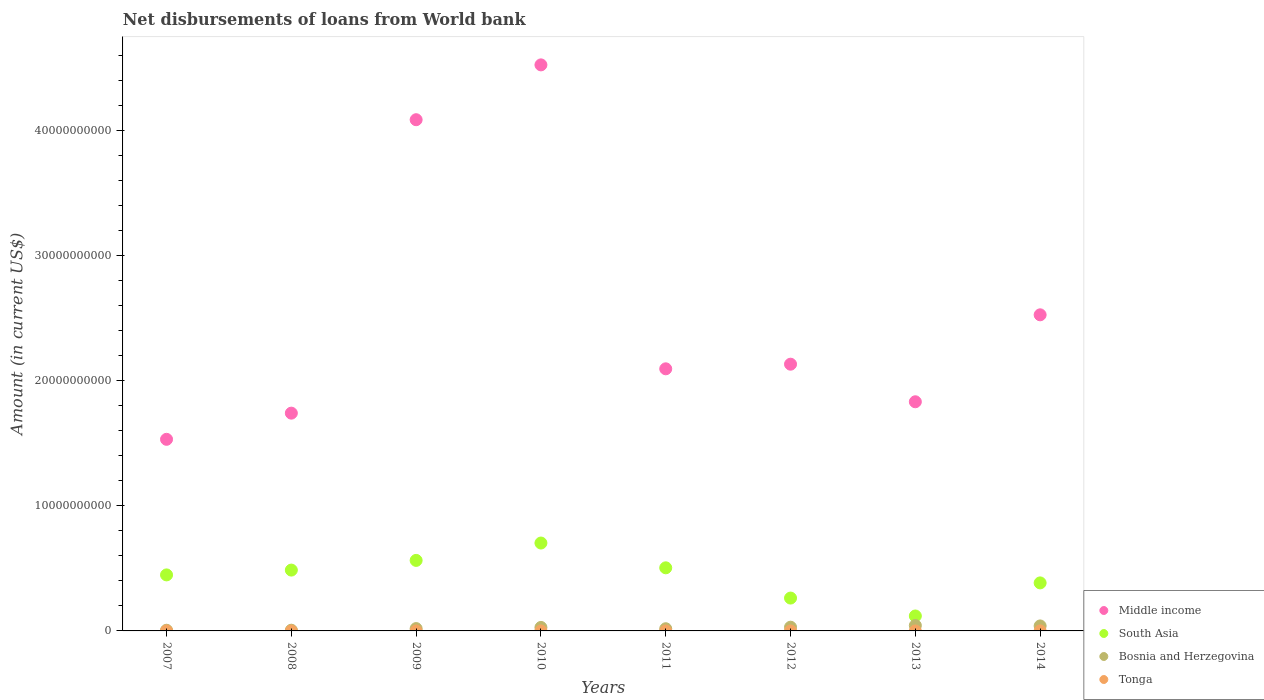What is the amount of loan disbursed from World Bank in South Asia in 2010?
Your answer should be compact. 7.02e+09. Across all years, what is the maximum amount of loan disbursed from World Bank in Middle income?
Keep it short and to the point. 4.52e+1. Across all years, what is the minimum amount of loan disbursed from World Bank in South Asia?
Your answer should be very brief. 1.19e+09. In which year was the amount of loan disbursed from World Bank in South Asia maximum?
Provide a succinct answer. 2010. What is the total amount of loan disbursed from World Bank in Bosnia and Herzegovina in the graph?
Make the answer very short. 1.88e+09. What is the difference between the amount of loan disbursed from World Bank in Middle income in 2008 and that in 2013?
Make the answer very short. -9.09e+08. What is the difference between the amount of loan disbursed from World Bank in Middle income in 2011 and the amount of loan disbursed from World Bank in Bosnia and Herzegovina in 2009?
Make the answer very short. 2.08e+1. What is the average amount of loan disbursed from World Bank in Tonga per year?
Offer a very short reply. 5.67e+05. In the year 2011, what is the difference between the amount of loan disbursed from World Bank in Bosnia and Herzegovina and amount of loan disbursed from World Bank in South Asia?
Keep it short and to the point. -4.87e+09. What is the ratio of the amount of loan disbursed from World Bank in Middle income in 2008 to that in 2012?
Provide a succinct answer. 0.82. Is the amount of loan disbursed from World Bank in Tonga in 2007 less than that in 2009?
Provide a succinct answer. No. Is the difference between the amount of loan disbursed from World Bank in Bosnia and Herzegovina in 2007 and 2008 greater than the difference between the amount of loan disbursed from World Bank in South Asia in 2007 and 2008?
Offer a terse response. Yes. What is the difference between the highest and the second highest amount of loan disbursed from World Bank in South Asia?
Ensure brevity in your answer.  1.39e+09. What is the difference between the highest and the lowest amount of loan disbursed from World Bank in Tonga?
Offer a terse response. 2.32e+06. Is the sum of the amount of loan disbursed from World Bank in Bosnia and Herzegovina in 2009 and 2012 greater than the maximum amount of loan disbursed from World Bank in Tonga across all years?
Ensure brevity in your answer.  Yes. Is it the case that in every year, the sum of the amount of loan disbursed from World Bank in Middle income and amount of loan disbursed from World Bank in Bosnia and Herzegovina  is greater than the amount of loan disbursed from World Bank in Tonga?
Give a very brief answer. Yes. Does the amount of loan disbursed from World Bank in Tonga monotonically increase over the years?
Offer a very short reply. No. Is the amount of loan disbursed from World Bank in Bosnia and Herzegovina strictly greater than the amount of loan disbursed from World Bank in South Asia over the years?
Provide a short and direct response. No. What is the difference between two consecutive major ticks on the Y-axis?
Your answer should be very brief. 1.00e+1. Does the graph contain any zero values?
Offer a very short reply. Yes. Where does the legend appear in the graph?
Your response must be concise. Bottom right. What is the title of the graph?
Your answer should be compact. Net disbursements of loans from World bank. Does "West Bank and Gaza" appear as one of the legend labels in the graph?
Keep it short and to the point. No. What is the label or title of the Y-axis?
Your response must be concise. Amount (in current US$). What is the Amount (in current US$) in Middle income in 2007?
Offer a terse response. 1.53e+1. What is the Amount (in current US$) of South Asia in 2007?
Give a very brief answer. 4.48e+09. What is the Amount (in current US$) of Bosnia and Herzegovina in 2007?
Your answer should be very brief. 5.48e+07. What is the Amount (in current US$) in Tonga in 2007?
Make the answer very short. 2.32e+06. What is the Amount (in current US$) of Middle income in 2008?
Your answer should be very brief. 1.74e+1. What is the Amount (in current US$) of South Asia in 2008?
Ensure brevity in your answer.  4.86e+09. What is the Amount (in current US$) in Bosnia and Herzegovina in 2008?
Offer a terse response. 5.72e+07. What is the Amount (in current US$) of Middle income in 2009?
Offer a terse response. 4.08e+1. What is the Amount (in current US$) of South Asia in 2009?
Keep it short and to the point. 5.63e+09. What is the Amount (in current US$) in Bosnia and Herzegovina in 2009?
Provide a short and direct response. 1.87e+08. What is the Amount (in current US$) in Tonga in 2009?
Offer a terse response. 5.30e+04. What is the Amount (in current US$) of Middle income in 2010?
Your answer should be very brief. 4.52e+1. What is the Amount (in current US$) of South Asia in 2010?
Your answer should be very brief. 7.02e+09. What is the Amount (in current US$) in Bosnia and Herzegovina in 2010?
Your answer should be very brief. 2.78e+08. What is the Amount (in current US$) of Middle income in 2011?
Provide a short and direct response. 2.09e+1. What is the Amount (in current US$) in South Asia in 2011?
Make the answer very short. 5.04e+09. What is the Amount (in current US$) of Bosnia and Herzegovina in 2011?
Make the answer very short. 1.75e+08. What is the Amount (in current US$) in Middle income in 2012?
Offer a very short reply. 2.13e+1. What is the Amount (in current US$) of South Asia in 2012?
Ensure brevity in your answer.  2.63e+09. What is the Amount (in current US$) of Bosnia and Herzegovina in 2012?
Keep it short and to the point. 2.98e+08. What is the Amount (in current US$) in Middle income in 2013?
Your answer should be compact. 1.83e+1. What is the Amount (in current US$) of South Asia in 2013?
Your response must be concise. 1.19e+09. What is the Amount (in current US$) of Bosnia and Herzegovina in 2013?
Provide a succinct answer. 4.33e+08. What is the Amount (in current US$) of Middle income in 2014?
Your answer should be compact. 2.53e+1. What is the Amount (in current US$) in South Asia in 2014?
Your answer should be compact. 3.84e+09. What is the Amount (in current US$) in Bosnia and Herzegovina in 2014?
Your answer should be compact. 3.98e+08. What is the Amount (in current US$) in Tonga in 2014?
Your answer should be very brief. 2.16e+06. Across all years, what is the maximum Amount (in current US$) in Middle income?
Your response must be concise. 4.52e+1. Across all years, what is the maximum Amount (in current US$) in South Asia?
Provide a short and direct response. 7.02e+09. Across all years, what is the maximum Amount (in current US$) of Bosnia and Herzegovina?
Ensure brevity in your answer.  4.33e+08. Across all years, what is the maximum Amount (in current US$) in Tonga?
Your answer should be very brief. 2.32e+06. Across all years, what is the minimum Amount (in current US$) in Middle income?
Provide a succinct answer. 1.53e+1. Across all years, what is the minimum Amount (in current US$) in South Asia?
Make the answer very short. 1.19e+09. Across all years, what is the minimum Amount (in current US$) of Bosnia and Herzegovina?
Keep it short and to the point. 5.48e+07. Across all years, what is the minimum Amount (in current US$) of Tonga?
Give a very brief answer. 0. What is the total Amount (in current US$) of Middle income in the graph?
Offer a very short reply. 2.05e+11. What is the total Amount (in current US$) in South Asia in the graph?
Your answer should be very brief. 3.47e+1. What is the total Amount (in current US$) of Bosnia and Herzegovina in the graph?
Give a very brief answer. 1.88e+09. What is the total Amount (in current US$) in Tonga in the graph?
Give a very brief answer. 4.54e+06. What is the difference between the Amount (in current US$) in Middle income in 2007 and that in 2008?
Your answer should be very brief. -2.09e+09. What is the difference between the Amount (in current US$) in South Asia in 2007 and that in 2008?
Your answer should be compact. -3.85e+08. What is the difference between the Amount (in current US$) in Bosnia and Herzegovina in 2007 and that in 2008?
Give a very brief answer. -2.36e+06. What is the difference between the Amount (in current US$) in Middle income in 2007 and that in 2009?
Your answer should be very brief. -2.55e+1. What is the difference between the Amount (in current US$) in South Asia in 2007 and that in 2009?
Your answer should be very brief. -1.16e+09. What is the difference between the Amount (in current US$) of Bosnia and Herzegovina in 2007 and that in 2009?
Your response must be concise. -1.32e+08. What is the difference between the Amount (in current US$) of Tonga in 2007 and that in 2009?
Ensure brevity in your answer.  2.27e+06. What is the difference between the Amount (in current US$) of Middle income in 2007 and that in 2010?
Provide a short and direct response. -2.99e+1. What is the difference between the Amount (in current US$) in South Asia in 2007 and that in 2010?
Give a very brief answer. -2.55e+09. What is the difference between the Amount (in current US$) in Bosnia and Herzegovina in 2007 and that in 2010?
Your response must be concise. -2.23e+08. What is the difference between the Amount (in current US$) in Middle income in 2007 and that in 2011?
Ensure brevity in your answer.  -5.63e+09. What is the difference between the Amount (in current US$) in South Asia in 2007 and that in 2011?
Offer a terse response. -5.66e+08. What is the difference between the Amount (in current US$) in Bosnia and Herzegovina in 2007 and that in 2011?
Provide a succinct answer. -1.20e+08. What is the difference between the Amount (in current US$) of Middle income in 2007 and that in 2012?
Your response must be concise. -6.00e+09. What is the difference between the Amount (in current US$) of South Asia in 2007 and that in 2012?
Provide a short and direct response. 1.85e+09. What is the difference between the Amount (in current US$) in Bosnia and Herzegovina in 2007 and that in 2012?
Your answer should be very brief. -2.43e+08. What is the difference between the Amount (in current US$) of Middle income in 2007 and that in 2013?
Keep it short and to the point. -3.00e+09. What is the difference between the Amount (in current US$) in South Asia in 2007 and that in 2013?
Your answer should be very brief. 3.28e+09. What is the difference between the Amount (in current US$) in Bosnia and Herzegovina in 2007 and that in 2013?
Give a very brief answer. -3.78e+08. What is the difference between the Amount (in current US$) in Middle income in 2007 and that in 2014?
Your answer should be very brief. -9.95e+09. What is the difference between the Amount (in current US$) of South Asia in 2007 and that in 2014?
Your response must be concise. 6.39e+08. What is the difference between the Amount (in current US$) of Bosnia and Herzegovina in 2007 and that in 2014?
Provide a short and direct response. -3.43e+08. What is the difference between the Amount (in current US$) of Tonga in 2007 and that in 2014?
Your answer should be very brief. 1.64e+05. What is the difference between the Amount (in current US$) of Middle income in 2008 and that in 2009?
Offer a terse response. -2.34e+1. What is the difference between the Amount (in current US$) in South Asia in 2008 and that in 2009?
Offer a very short reply. -7.74e+08. What is the difference between the Amount (in current US$) of Bosnia and Herzegovina in 2008 and that in 2009?
Provide a succinct answer. -1.29e+08. What is the difference between the Amount (in current US$) of Middle income in 2008 and that in 2010?
Keep it short and to the point. -2.78e+1. What is the difference between the Amount (in current US$) of South Asia in 2008 and that in 2010?
Your answer should be very brief. -2.16e+09. What is the difference between the Amount (in current US$) in Bosnia and Herzegovina in 2008 and that in 2010?
Your answer should be very brief. -2.20e+08. What is the difference between the Amount (in current US$) of Middle income in 2008 and that in 2011?
Keep it short and to the point. -3.54e+09. What is the difference between the Amount (in current US$) of South Asia in 2008 and that in 2011?
Your answer should be compact. -1.82e+08. What is the difference between the Amount (in current US$) of Bosnia and Herzegovina in 2008 and that in 2011?
Your answer should be very brief. -1.18e+08. What is the difference between the Amount (in current US$) of Middle income in 2008 and that in 2012?
Provide a succinct answer. -3.91e+09. What is the difference between the Amount (in current US$) of South Asia in 2008 and that in 2012?
Provide a succinct answer. 2.24e+09. What is the difference between the Amount (in current US$) of Bosnia and Herzegovina in 2008 and that in 2012?
Your answer should be very brief. -2.41e+08. What is the difference between the Amount (in current US$) in Middle income in 2008 and that in 2013?
Your answer should be very brief. -9.09e+08. What is the difference between the Amount (in current US$) of South Asia in 2008 and that in 2013?
Provide a succinct answer. 3.67e+09. What is the difference between the Amount (in current US$) in Bosnia and Herzegovina in 2008 and that in 2013?
Your answer should be very brief. -3.76e+08. What is the difference between the Amount (in current US$) of Middle income in 2008 and that in 2014?
Keep it short and to the point. -7.86e+09. What is the difference between the Amount (in current US$) in South Asia in 2008 and that in 2014?
Your answer should be very brief. 1.02e+09. What is the difference between the Amount (in current US$) of Bosnia and Herzegovina in 2008 and that in 2014?
Give a very brief answer. -3.41e+08. What is the difference between the Amount (in current US$) in Middle income in 2009 and that in 2010?
Give a very brief answer. -4.38e+09. What is the difference between the Amount (in current US$) of South Asia in 2009 and that in 2010?
Make the answer very short. -1.39e+09. What is the difference between the Amount (in current US$) of Bosnia and Herzegovina in 2009 and that in 2010?
Make the answer very short. -9.10e+07. What is the difference between the Amount (in current US$) of Middle income in 2009 and that in 2011?
Your answer should be compact. 1.99e+1. What is the difference between the Amount (in current US$) of South Asia in 2009 and that in 2011?
Ensure brevity in your answer.  5.92e+08. What is the difference between the Amount (in current US$) in Bosnia and Herzegovina in 2009 and that in 2011?
Give a very brief answer. 1.18e+07. What is the difference between the Amount (in current US$) of Middle income in 2009 and that in 2012?
Give a very brief answer. 1.95e+1. What is the difference between the Amount (in current US$) in South Asia in 2009 and that in 2012?
Ensure brevity in your answer.  3.01e+09. What is the difference between the Amount (in current US$) of Bosnia and Herzegovina in 2009 and that in 2012?
Your response must be concise. -1.12e+08. What is the difference between the Amount (in current US$) in Middle income in 2009 and that in 2013?
Ensure brevity in your answer.  2.25e+1. What is the difference between the Amount (in current US$) in South Asia in 2009 and that in 2013?
Your response must be concise. 4.44e+09. What is the difference between the Amount (in current US$) in Bosnia and Herzegovina in 2009 and that in 2013?
Provide a short and direct response. -2.46e+08. What is the difference between the Amount (in current US$) in Middle income in 2009 and that in 2014?
Your answer should be very brief. 1.56e+1. What is the difference between the Amount (in current US$) in South Asia in 2009 and that in 2014?
Offer a very short reply. 1.80e+09. What is the difference between the Amount (in current US$) of Bosnia and Herzegovina in 2009 and that in 2014?
Provide a succinct answer. -2.12e+08. What is the difference between the Amount (in current US$) in Tonga in 2009 and that in 2014?
Provide a short and direct response. -2.11e+06. What is the difference between the Amount (in current US$) in Middle income in 2010 and that in 2011?
Your answer should be very brief. 2.43e+1. What is the difference between the Amount (in current US$) in South Asia in 2010 and that in 2011?
Offer a very short reply. 1.98e+09. What is the difference between the Amount (in current US$) of Bosnia and Herzegovina in 2010 and that in 2011?
Your answer should be compact. 1.03e+08. What is the difference between the Amount (in current US$) in Middle income in 2010 and that in 2012?
Ensure brevity in your answer.  2.39e+1. What is the difference between the Amount (in current US$) in South Asia in 2010 and that in 2012?
Keep it short and to the point. 4.40e+09. What is the difference between the Amount (in current US$) of Bosnia and Herzegovina in 2010 and that in 2012?
Provide a succinct answer. -2.07e+07. What is the difference between the Amount (in current US$) in Middle income in 2010 and that in 2013?
Offer a terse response. 2.69e+1. What is the difference between the Amount (in current US$) of South Asia in 2010 and that in 2013?
Ensure brevity in your answer.  5.83e+09. What is the difference between the Amount (in current US$) in Bosnia and Herzegovina in 2010 and that in 2013?
Your answer should be very brief. -1.55e+08. What is the difference between the Amount (in current US$) in Middle income in 2010 and that in 2014?
Offer a very short reply. 2.00e+1. What is the difference between the Amount (in current US$) in South Asia in 2010 and that in 2014?
Your answer should be very brief. 3.19e+09. What is the difference between the Amount (in current US$) in Bosnia and Herzegovina in 2010 and that in 2014?
Your answer should be very brief. -1.21e+08. What is the difference between the Amount (in current US$) of Middle income in 2011 and that in 2012?
Ensure brevity in your answer.  -3.69e+08. What is the difference between the Amount (in current US$) in South Asia in 2011 and that in 2012?
Offer a very short reply. 2.42e+09. What is the difference between the Amount (in current US$) of Bosnia and Herzegovina in 2011 and that in 2012?
Keep it short and to the point. -1.23e+08. What is the difference between the Amount (in current US$) in Middle income in 2011 and that in 2013?
Your answer should be very brief. 2.63e+09. What is the difference between the Amount (in current US$) in South Asia in 2011 and that in 2013?
Your answer should be very brief. 3.85e+09. What is the difference between the Amount (in current US$) of Bosnia and Herzegovina in 2011 and that in 2013?
Make the answer very short. -2.58e+08. What is the difference between the Amount (in current US$) in Middle income in 2011 and that in 2014?
Offer a very short reply. -4.31e+09. What is the difference between the Amount (in current US$) in South Asia in 2011 and that in 2014?
Your answer should be very brief. 1.21e+09. What is the difference between the Amount (in current US$) in Bosnia and Herzegovina in 2011 and that in 2014?
Offer a very short reply. -2.23e+08. What is the difference between the Amount (in current US$) of Middle income in 2012 and that in 2013?
Make the answer very short. 3.00e+09. What is the difference between the Amount (in current US$) of South Asia in 2012 and that in 2013?
Make the answer very short. 1.43e+09. What is the difference between the Amount (in current US$) of Bosnia and Herzegovina in 2012 and that in 2013?
Ensure brevity in your answer.  -1.35e+08. What is the difference between the Amount (in current US$) in Middle income in 2012 and that in 2014?
Ensure brevity in your answer.  -3.94e+09. What is the difference between the Amount (in current US$) of South Asia in 2012 and that in 2014?
Offer a very short reply. -1.21e+09. What is the difference between the Amount (in current US$) of Bosnia and Herzegovina in 2012 and that in 2014?
Ensure brevity in your answer.  -1.00e+08. What is the difference between the Amount (in current US$) of Middle income in 2013 and that in 2014?
Provide a short and direct response. -6.95e+09. What is the difference between the Amount (in current US$) of South Asia in 2013 and that in 2014?
Make the answer very short. -2.64e+09. What is the difference between the Amount (in current US$) of Bosnia and Herzegovina in 2013 and that in 2014?
Provide a succinct answer. 3.45e+07. What is the difference between the Amount (in current US$) of Middle income in 2007 and the Amount (in current US$) of South Asia in 2008?
Provide a short and direct response. 1.04e+1. What is the difference between the Amount (in current US$) in Middle income in 2007 and the Amount (in current US$) in Bosnia and Herzegovina in 2008?
Give a very brief answer. 1.53e+1. What is the difference between the Amount (in current US$) in South Asia in 2007 and the Amount (in current US$) in Bosnia and Herzegovina in 2008?
Your answer should be very brief. 4.42e+09. What is the difference between the Amount (in current US$) of Middle income in 2007 and the Amount (in current US$) of South Asia in 2009?
Ensure brevity in your answer.  9.67e+09. What is the difference between the Amount (in current US$) of Middle income in 2007 and the Amount (in current US$) of Bosnia and Herzegovina in 2009?
Give a very brief answer. 1.51e+1. What is the difference between the Amount (in current US$) in Middle income in 2007 and the Amount (in current US$) in Tonga in 2009?
Your answer should be compact. 1.53e+1. What is the difference between the Amount (in current US$) in South Asia in 2007 and the Amount (in current US$) in Bosnia and Herzegovina in 2009?
Keep it short and to the point. 4.29e+09. What is the difference between the Amount (in current US$) in South Asia in 2007 and the Amount (in current US$) in Tonga in 2009?
Offer a very short reply. 4.48e+09. What is the difference between the Amount (in current US$) of Bosnia and Herzegovina in 2007 and the Amount (in current US$) of Tonga in 2009?
Your answer should be very brief. 5.48e+07. What is the difference between the Amount (in current US$) of Middle income in 2007 and the Amount (in current US$) of South Asia in 2010?
Offer a very short reply. 8.29e+09. What is the difference between the Amount (in current US$) in Middle income in 2007 and the Amount (in current US$) in Bosnia and Herzegovina in 2010?
Offer a terse response. 1.50e+1. What is the difference between the Amount (in current US$) of South Asia in 2007 and the Amount (in current US$) of Bosnia and Herzegovina in 2010?
Your response must be concise. 4.20e+09. What is the difference between the Amount (in current US$) of Middle income in 2007 and the Amount (in current US$) of South Asia in 2011?
Your answer should be very brief. 1.03e+1. What is the difference between the Amount (in current US$) of Middle income in 2007 and the Amount (in current US$) of Bosnia and Herzegovina in 2011?
Provide a succinct answer. 1.51e+1. What is the difference between the Amount (in current US$) in South Asia in 2007 and the Amount (in current US$) in Bosnia and Herzegovina in 2011?
Your response must be concise. 4.30e+09. What is the difference between the Amount (in current US$) in Middle income in 2007 and the Amount (in current US$) in South Asia in 2012?
Offer a very short reply. 1.27e+1. What is the difference between the Amount (in current US$) of Middle income in 2007 and the Amount (in current US$) of Bosnia and Herzegovina in 2012?
Offer a terse response. 1.50e+1. What is the difference between the Amount (in current US$) in South Asia in 2007 and the Amount (in current US$) in Bosnia and Herzegovina in 2012?
Provide a short and direct response. 4.18e+09. What is the difference between the Amount (in current US$) in Middle income in 2007 and the Amount (in current US$) in South Asia in 2013?
Provide a succinct answer. 1.41e+1. What is the difference between the Amount (in current US$) in Middle income in 2007 and the Amount (in current US$) in Bosnia and Herzegovina in 2013?
Offer a terse response. 1.49e+1. What is the difference between the Amount (in current US$) in South Asia in 2007 and the Amount (in current US$) in Bosnia and Herzegovina in 2013?
Your answer should be very brief. 4.04e+09. What is the difference between the Amount (in current US$) in Middle income in 2007 and the Amount (in current US$) in South Asia in 2014?
Your response must be concise. 1.15e+1. What is the difference between the Amount (in current US$) of Middle income in 2007 and the Amount (in current US$) of Bosnia and Herzegovina in 2014?
Give a very brief answer. 1.49e+1. What is the difference between the Amount (in current US$) of Middle income in 2007 and the Amount (in current US$) of Tonga in 2014?
Your answer should be compact. 1.53e+1. What is the difference between the Amount (in current US$) in South Asia in 2007 and the Amount (in current US$) in Bosnia and Herzegovina in 2014?
Provide a short and direct response. 4.08e+09. What is the difference between the Amount (in current US$) in South Asia in 2007 and the Amount (in current US$) in Tonga in 2014?
Provide a short and direct response. 4.47e+09. What is the difference between the Amount (in current US$) of Bosnia and Herzegovina in 2007 and the Amount (in current US$) of Tonga in 2014?
Offer a very short reply. 5.27e+07. What is the difference between the Amount (in current US$) of Middle income in 2008 and the Amount (in current US$) of South Asia in 2009?
Your answer should be very brief. 1.18e+1. What is the difference between the Amount (in current US$) of Middle income in 2008 and the Amount (in current US$) of Bosnia and Herzegovina in 2009?
Offer a terse response. 1.72e+1. What is the difference between the Amount (in current US$) in Middle income in 2008 and the Amount (in current US$) in Tonga in 2009?
Your answer should be very brief. 1.74e+1. What is the difference between the Amount (in current US$) of South Asia in 2008 and the Amount (in current US$) of Bosnia and Herzegovina in 2009?
Offer a very short reply. 4.67e+09. What is the difference between the Amount (in current US$) of South Asia in 2008 and the Amount (in current US$) of Tonga in 2009?
Offer a terse response. 4.86e+09. What is the difference between the Amount (in current US$) of Bosnia and Herzegovina in 2008 and the Amount (in current US$) of Tonga in 2009?
Keep it short and to the point. 5.71e+07. What is the difference between the Amount (in current US$) of Middle income in 2008 and the Amount (in current US$) of South Asia in 2010?
Provide a short and direct response. 1.04e+1. What is the difference between the Amount (in current US$) of Middle income in 2008 and the Amount (in current US$) of Bosnia and Herzegovina in 2010?
Give a very brief answer. 1.71e+1. What is the difference between the Amount (in current US$) of South Asia in 2008 and the Amount (in current US$) of Bosnia and Herzegovina in 2010?
Make the answer very short. 4.58e+09. What is the difference between the Amount (in current US$) in Middle income in 2008 and the Amount (in current US$) in South Asia in 2011?
Your answer should be compact. 1.24e+1. What is the difference between the Amount (in current US$) of Middle income in 2008 and the Amount (in current US$) of Bosnia and Herzegovina in 2011?
Your response must be concise. 1.72e+1. What is the difference between the Amount (in current US$) in South Asia in 2008 and the Amount (in current US$) in Bosnia and Herzegovina in 2011?
Your answer should be very brief. 4.69e+09. What is the difference between the Amount (in current US$) of Middle income in 2008 and the Amount (in current US$) of South Asia in 2012?
Ensure brevity in your answer.  1.48e+1. What is the difference between the Amount (in current US$) of Middle income in 2008 and the Amount (in current US$) of Bosnia and Herzegovina in 2012?
Offer a terse response. 1.71e+1. What is the difference between the Amount (in current US$) in South Asia in 2008 and the Amount (in current US$) in Bosnia and Herzegovina in 2012?
Make the answer very short. 4.56e+09. What is the difference between the Amount (in current US$) in Middle income in 2008 and the Amount (in current US$) in South Asia in 2013?
Your answer should be compact. 1.62e+1. What is the difference between the Amount (in current US$) of Middle income in 2008 and the Amount (in current US$) of Bosnia and Herzegovina in 2013?
Provide a succinct answer. 1.70e+1. What is the difference between the Amount (in current US$) in South Asia in 2008 and the Amount (in current US$) in Bosnia and Herzegovina in 2013?
Keep it short and to the point. 4.43e+09. What is the difference between the Amount (in current US$) in Middle income in 2008 and the Amount (in current US$) in South Asia in 2014?
Offer a terse response. 1.36e+1. What is the difference between the Amount (in current US$) in Middle income in 2008 and the Amount (in current US$) in Bosnia and Herzegovina in 2014?
Ensure brevity in your answer.  1.70e+1. What is the difference between the Amount (in current US$) of Middle income in 2008 and the Amount (in current US$) of Tonga in 2014?
Your answer should be very brief. 1.74e+1. What is the difference between the Amount (in current US$) of South Asia in 2008 and the Amount (in current US$) of Bosnia and Herzegovina in 2014?
Provide a short and direct response. 4.46e+09. What is the difference between the Amount (in current US$) of South Asia in 2008 and the Amount (in current US$) of Tonga in 2014?
Your response must be concise. 4.86e+09. What is the difference between the Amount (in current US$) in Bosnia and Herzegovina in 2008 and the Amount (in current US$) in Tonga in 2014?
Make the answer very short. 5.50e+07. What is the difference between the Amount (in current US$) in Middle income in 2009 and the Amount (in current US$) in South Asia in 2010?
Keep it short and to the point. 3.38e+1. What is the difference between the Amount (in current US$) in Middle income in 2009 and the Amount (in current US$) in Bosnia and Herzegovina in 2010?
Keep it short and to the point. 4.06e+1. What is the difference between the Amount (in current US$) in South Asia in 2009 and the Amount (in current US$) in Bosnia and Herzegovina in 2010?
Provide a succinct answer. 5.36e+09. What is the difference between the Amount (in current US$) of Middle income in 2009 and the Amount (in current US$) of South Asia in 2011?
Provide a succinct answer. 3.58e+1. What is the difference between the Amount (in current US$) of Middle income in 2009 and the Amount (in current US$) of Bosnia and Herzegovina in 2011?
Your response must be concise. 4.07e+1. What is the difference between the Amount (in current US$) in South Asia in 2009 and the Amount (in current US$) in Bosnia and Herzegovina in 2011?
Provide a short and direct response. 5.46e+09. What is the difference between the Amount (in current US$) of Middle income in 2009 and the Amount (in current US$) of South Asia in 2012?
Provide a short and direct response. 3.82e+1. What is the difference between the Amount (in current US$) of Middle income in 2009 and the Amount (in current US$) of Bosnia and Herzegovina in 2012?
Make the answer very short. 4.05e+1. What is the difference between the Amount (in current US$) of South Asia in 2009 and the Amount (in current US$) of Bosnia and Herzegovina in 2012?
Your answer should be very brief. 5.34e+09. What is the difference between the Amount (in current US$) of Middle income in 2009 and the Amount (in current US$) of South Asia in 2013?
Offer a very short reply. 3.97e+1. What is the difference between the Amount (in current US$) of Middle income in 2009 and the Amount (in current US$) of Bosnia and Herzegovina in 2013?
Make the answer very short. 4.04e+1. What is the difference between the Amount (in current US$) of South Asia in 2009 and the Amount (in current US$) of Bosnia and Herzegovina in 2013?
Your response must be concise. 5.20e+09. What is the difference between the Amount (in current US$) of Middle income in 2009 and the Amount (in current US$) of South Asia in 2014?
Your answer should be compact. 3.70e+1. What is the difference between the Amount (in current US$) of Middle income in 2009 and the Amount (in current US$) of Bosnia and Herzegovina in 2014?
Offer a terse response. 4.04e+1. What is the difference between the Amount (in current US$) of Middle income in 2009 and the Amount (in current US$) of Tonga in 2014?
Give a very brief answer. 4.08e+1. What is the difference between the Amount (in current US$) of South Asia in 2009 and the Amount (in current US$) of Bosnia and Herzegovina in 2014?
Provide a succinct answer. 5.24e+09. What is the difference between the Amount (in current US$) in South Asia in 2009 and the Amount (in current US$) in Tonga in 2014?
Provide a succinct answer. 5.63e+09. What is the difference between the Amount (in current US$) of Bosnia and Herzegovina in 2009 and the Amount (in current US$) of Tonga in 2014?
Ensure brevity in your answer.  1.84e+08. What is the difference between the Amount (in current US$) of Middle income in 2010 and the Amount (in current US$) of South Asia in 2011?
Your answer should be compact. 4.02e+1. What is the difference between the Amount (in current US$) of Middle income in 2010 and the Amount (in current US$) of Bosnia and Herzegovina in 2011?
Make the answer very short. 4.51e+1. What is the difference between the Amount (in current US$) of South Asia in 2010 and the Amount (in current US$) of Bosnia and Herzegovina in 2011?
Offer a terse response. 6.85e+09. What is the difference between the Amount (in current US$) of Middle income in 2010 and the Amount (in current US$) of South Asia in 2012?
Offer a very short reply. 4.26e+1. What is the difference between the Amount (in current US$) in Middle income in 2010 and the Amount (in current US$) in Bosnia and Herzegovina in 2012?
Provide a succinct answer. 4.49e+1. What is the difference between the Amount (in current US$) in South Asia in 2010 and the Amount (in current US$) in Bosnia and Herzegovina in 2012?
Offer a terse response. 6.72e+09. What is the difference between the Amount (in current US$) in Middle income in 2010 and the Amount (in current US$) in South Asia in 2013?
Your answer should be very brief. 4.40e+1. What is the difference between the Amount (in current US$) in Middle income in 2010 and the Amount (in current US$) in Bosnia and Herzegovina in 2013?
Offer a terse response. 4.48e+1. What is the difference between the Amount (in current US$) in South Asia in 2010 and the Amount (in current US$) in Bosnia and Herzegovina in 2013?
Ensure brevity in your answer.  6.59e+09. What is the difference between the Amount (in current US$) in Middle income in 2010 and the Amount (in current US$) in South Asia in 2014?
Your answer should be very brief. 4.14e+1. What is the difference between the Amount (in current US$) of Middle income in 2010 and the Amount (in current US$) of Bosnia and Herzegovina in 2014?
Offer a terse response. 4.48e+1. What is the difference between the Amount (in current US$) in Middle income in 2010 and the Amount (in current US$) in Tonga in 2014?
Offer a terse response. 4.52e+1. What is the difference between the Amount (in current US$) in South Asia in 2010 and the Amount (in current US$) in Bosnia and Herzegovina in 2014?
Your answer should be compact. 6.62e+09. What is the difference between the Amount (in current US$) in South Asia in 2010 and the Amount (in current US$) in Tonga in 2014?
Provide a short and direct response. 7.02e+09. What is the difference between the Amount (in current US$) of Bosnia and Herzegovina in 2010 and the Amount (in current US$) of Tonga in 2014?
Keep it short and to the point. 2.75e+08. What is the difference between the Amount (in current US$) of Middle income in 2011 and the Amount (in current US$) of South Asia in 2012?
Provide a short and direct response. 1.83e+1. What is the difference between the Amount (in current US$) in Middle income in 2011 and the Amount (in current US$) in Bosnia and Herzegovina in 2012?
Provide a succinct answer. 2.06e+1. What is the difference between the Amount (in current US$) in South Asia in 2011 and the Amount (in current US$) in Bosnia and Herzegovina in 2012?
Your answer should be very brief. 4.74e+09. What is the difference between the Amount (in current US$) of Middle income in 2011 and the Amount (in current US$) of South Asia in 2013?
Make the answer very short. 1.97e+1. What is the difference between the Amount (in current US$) of Middle income in 2011 and the Amount (in current US$) of Bosnia and Herzegovina in 2013?
Provide a succinct answer. 2.05e+1. What is the difference between the Amount (in current US$) in South Asia in 2011 and the Amount (in current US$) in Bosnia and Herzegovina in 2013?
Your answer should be very brief. 4.61e+09. What is the difference between the Amount (in current US$) of Middle income in 2011 and the Amount (in current US$) of South Asia in 2014?
Offer a very short reply. 1.71e+1. What is the difference between the Amount (in current US$) in Middle income in 2011 and the Amount (in current US$) in Bosnia and Herzegovina in 2014?
Provide a short and direct response. 2.05e+1. What is the difference between the Amount (in current US$) in Middle income in 2011 and the Amount (in current US$) in Tonga in 2014?
Provide a succinct answer. 2.09e+1. What is the difference between the Amount (in current US$) in South Asia in 2011 and the Amount (in current US$) in Bosnia and Herzegovina in 2014?
Offer a terse response. 4.64e+09. What is the difference between the Amount (in current US$) of South Asia in 2011 and the Amount (in current US$) of Tonga in 2014?
Ensure brevity in your answer.  5.04e+09. What is the difference between the Amount (in current US$) in Bosnia and Herzegovina in 2011 and the Amount (in current US$) in Tonga in 2014?
Offer a very short reply. 1.73e+08. What is the difference between the Amount (in current US$) in Middle income in 2012 and the Amount (in current US$) in South Asia in 2013?
Make the answer very short. 2.01e+1. What is the difference between the Amount (in current US$) in Middle income in 2012 and the Amount (in current US$) in Bosnia and Herzegovina in 2013?
Keep it short and to the point. 2.09e+1. What is the difference between the Amount (in current US$) in South Asia in 2012 and the Amount (in current US$) in Bosnia and Herzegovina in 2013?
Provide a short and direct response. 2.19e+09. What is the difference between the Amount (in current US$) in Middle income in 2012 and the Amount (in current US$) in South Asia in 2014?
Your answer should be compact. 1.75e+1. What is the difference between the Amount (in current US$) of Middle income in 2012 and the Amount (in current US$) of Bosnia and Herzegovina in 2014?
Your response must be concise. 2.09e+1. What is the difference between the Amount (in current US$) of Middle income in 2012 and the Amount (in current US$) of Tonga in 2014?
Your response must be concise. 2.13e+1. What is the difference between the Amount (in current US$) in South Asia in 2012 and the Amount (in current US$) in Bosnia and Herzegovina in 2014?
Offer a terse response. 2.23e+09. What is the difference between the Amount (in current US$) in South Asia in 2012 and the Amount (in current US$) in Tonga in 2014?
Keep it short and to the point. 2.62e+09. What is the difference between the Amount (in current US$) of Bosnia and Herzegovina in 2012 and the Amount (in current US$) of Tonga in 2014?
Provide a succinct answer. 2.96e+08. What is the difference between the Amount (in current US$) of Middle income in 2013 and the Amount (in current US$) of South Asia in 2014?
Provide a short and direct response. 1.45e+1. What is the difference between the Amount (in current US$) in Middle income in 2013 and the Amount (in current US$) in Bosnia and Herzegovina in 2014?
Keep it short and to the point. 1.79e+1. What is the difference between the Amount (in current US$) of Middle income in 2013 and the Amount (in current US$) of Tonga in 2014?
Keep it short and to the point. 1.83e+1. What is the difference between the Amount (in current US$) of South Asia in 2013 and the Amount (in current US$) of Bosnia and Herzegovina in 2014?
Offer a very short reply. 7.96e+08. What is the difference between the Amount (in current US$) in South Asia in 2013 and the Amount (in current US$) in Tonga in 2014?
Keep it short and to the point. 1.19e+09. What is the difference between the Amount (in current US$) in Bosnia and Herzegovina in 2013 and the Amount (in current US$) in Tonga in 2014?
Your answer should be compact. 4.31e+08. What is the average Amount (in current US$) of Middle income per year?
Your answer should be very brief. 2.56e+1. What is the average Amount (in current US$) in South Asia per year?
Ensure brevity in your answer.  4.34e+09. What is the average Amount (in current US$) in Bosnia and Herzegovina per year?
Provide a short and direct response. 2.35e+08. What is the average Amount (in current US$) of Tonga per year?
Your response must be concise. 5.67e+05. In the year 2007, what is the difference between the Amount (in current US$) of Middle income and Amount (in current US$) of South Asia?
Your answer should be very brief. 1.08e+1. In the year 2007, what is the difference between the Amount (in current US$) in Middle income and Amount (in current US$) in Bosnia and Herzegovina?
Keep it short and to the point. 1.53e+1. In the year 2007, what is the difference between the Amount (in current US$) of Middle income and Amount (in current US$) of Tonga?
Your response must be concise. 1.53e+1. In the year 2007, what is the difference between the Amount (in current US$) in South Asia and Amount (in current US$) in Bosnia and Herzegovina?
Ensure brevity in your answer.  4.42e+09. In the year 2007, what is the difference between the Amount (in current US$) of South Asia and Amount (in current US$) of Tonga?
Your response must be concise. 4.47e+09. In the year 2007, what is the difference between the Amount (in current US$) of Bosnia and Herzegovina and Amount (in current US$) of Tonga?
Ensure brevity in your answer.  5.25e+07. In the year 2008, what is the difference between the Amount (in current US$) in Middle income and Amount (in current US$) in South Asia?
Offer a terse response. 1.25e+1. In the year 2008, what is the difference between the Amount (in current US$) of Middle income and Amount (in current US$) of Bosnia and Herzegovina?
Offer a very short reply. 1.73e+1. In the year 2008, what is the difference between the Amount (in current US$) of South Asia and Amount (in current US$) of Bosnia and Herzegovina?
Your answer should be very brief. 4.80e+09. In the year 2009, what is the difference between the Amount (in current US$) in Middle income and Amount (in current US$) in South Asia?
Provide a short and direct response. 3.52e+1. In the year 2009, what is the difference between the Amount (in current US$) of Middle income and Amount (in current US$) of Bosnia and Herzegovina?
Give a very brief answer. 4.07e+1. In the year 2009, what is the difference between the Amount (in current US$) of Middle income and Amount (in current US$) of Tonga?
Your answer should be very brief. 4.08e+1. In the year 2009, what is the difference between the Amount (in current US$) in South Asia and Amount (in current US$) in Bosnia and Herzegovina?
Your answer should be compact. 5.45e+09. In the year 2009, what is the difference between the Amount (in current US$) of South Asia and Amount (in current US$) of Tonga?
Offer a terse response. 5.63e+09. In the year 2009, what is the difference between the Amount (in current US$) of Bosnia and Herzegovina and Amount (in current US$) of Tonga?
Make the answer very short. 1.87e+08. In the year 2010, what is the difference between the Amount (in current US$) of Middle income and Amount (in current US$) of South Asia?
Offer a very short reply. 3.82e+1. In the year 2010, what is the difference between the Amount (in current US$) of Middle income and Amount (in current US$) of Bosnia and Herzegovina?
Offer a terse response. 4.49e+1. In the year 2010, what is the difference between the Amount (in current US$) in South Asia and Amount (in current US$) in Bosnia and Herzegovina?
Ensure brevity in your answer.  6.74e+09. In the year 2011, what is the difference between the Amount (in current US$) of Middle income and Amount (in current US$) of South Asia?
Provide a succinct answer. 1.59e+1. In the year 2011, what is the difference between the Amount (in current US$) of Middle income and Amount (in current US$) of Bosnia and Herzegovina?
Provide a succinct answer. 2.08e+1. In the year 2011, what is the difference between the Amount (in current US$) in South Asia and Amount (in current US$) in Bosnia and Herzegovina?
Provide a succinct answer. 4.87e+09. In the year 2012, what is the difference between the Amount (in current US$) of Middle income and Amount (in current US$) of South Asia?
Make the answer very short. 1.87e+1. In the year 2012, what is the difference between the Amount (in current US$) of Middle income and Amount (in current US$) of Bosnia and Herzegovina?
Keep it short and to the point. 2.10e+1. In the year 2012, what is the difference between the Amount (in current US$) of South Asia and Amount (in current US$) of Bosnia and Herzegovina?
Provide a succinct answer. 2.33e+09. In the year 2013, what is the difference between the Amount (in current US$) in Middle income and Amount (in current US$) in South Asia?
Give a very brief answer. 1.71e+1. In the year 2013, what is the difference between the Amount (in current US$) of Middle income and Amount (in current US$) of Bosnia and Herzegovina?
Provide a succinct answer. 1.79e+1. In the year 2013, what is the difference between the Amount (in current US$) in South Asia and Amount (in current US$) in Bosnia and Herzegovina?
Make the answer very short. 7.61e+08. In the year 2014, what is the difference between the Amount (in current US$) in Middle income and Amount (in current US$) in South Asia?
Keep it short and to the point. 2.14e+1. In the year 2014, what is the difference between the Amount (in current US$) of Middle income and Amount (in current US$) of Bosnia and Herzegovina?
Offer a terse response. 2.49e+1. In the year 2014, what is the difference between the Amount (in current US$) in Middle income and Amount (in current US$) in Tonga?
Make the answer very short. 2.53e+1. In the year 2014, what is the difference between the Amount (in current US$) in South Asia and Amount (in current US$) in Bosnia and Herzegovina?
Your response must be concise. 3.44e+09. In the year 2014, what is the difference between the Amount (in current US$) in South Asia and Amount (in current US$) in Tonga?
Make the answer very short. 3.83e+09. In the year 2014, what is the difference between the Amount (in current US$) of Bosnia and Herzegovina and Amount (in current US$) of Tonga?
Provide a succinct answer. 3.96e+08. What is the ratio of the Amount (in current US$) of Middle income in 2007 to that in 2008?
Provide a short and direct response. 0.88. What is the ratio of the Amount (in current US$) in South Asia in 2007 to that in 2008?
Provide a succinct answer. 0.92. What is the ratio of the Amount (in current US$) of Bosnia and Herzegovina in 2007 to that in 2008?
Offer a very short reply. 0.96. What is the ratio of the Amount (in current US$) in Middle income in 2007 to that in 2009?
Provide a short and direct response. 0.37. What is the ratio of the Amount (in current US$) of South Asia in 2007 to that in 2009?
Ensure brevity in your answer.  0.79. What is the ratio of the Amount (in current US$) of Bosnia and Herzegovina in 2007 to that in 2009?
Provide a short and direct response. 0.29. What is the ratio of the Amount (in current US$) of Tonga in 2007 to that in 2009?
Make the answer very short. 43.87. What is the ratio of the Amount (in current US$) in Middle income in 2007 to that in 2010?
Your answer should be compact. 0.34. What is the ratio of the Amount (in current US$) in South Asia in 2007 to that in 2010?
Keep it short and to the point. 0.64. What is the ratio of the Amount (in current US$) in Bosnia and Herzegovina in 2007 to that in 2010?
Your answer should be compact. 0.2. What is the ratio of the Amount (in current US$) in Middle income in 2007 to that in 2011?
Provide a short and direct response. 0.73. What is the ratio of the Amount (in current US$) in South Asia in 2007 to that in 2011?
Provide a succinct answer. 0.89. What is the ratio of the Amount (in current US$) in Bosnia and Herzegovina in 2007 to that in 2011?
Keep it short and to the point. 0.31. What is the ratio of the Amount (in current US$) of Middle income in 2007 to that in 2012?
Ensure brevity in your answer.  0.72. What is the ratio of the Amount (in current US$) of South Asia in 2007 to that in 2012?
Provide a succinct answer. 1.71. What is the ratio of the Amount (in current US$) of Bosnia and Herzegovina in 2007 to that in 2012?
Provide a short and direct response. 0.18. What is the ratio of the Amount (in current US$) of Middle income in 2007 to that in 2013?
Offer a terse response. 0.84. What is the ratio of the Amount (in current US$) of South Asia in 2007 to that in 2013?
Ensure brevity in your answer.  3.75. What is the ratio of the Amount (in current US$) in Bosnia and Herzegovina in 2007 to that in 2013?
Keep it short and to the point. 0.13. What is the ratio of the Amount (in current US$) of Middle income in 2007 to that in 2014?
Your answer should be compact. 0.61. What is the ratio of the Amount (in current US$) in South Asia in 2007 to that in 2014?
Offer a very short reply. 1.17. What is the ratio of the Amount (in current US$) of Bosnia and Herzegovina in 2007 to that in 2014?
Give a very brief answer. 0.14. What is the ratio of the Amount (in current US$) in Tonga in 2007 to that in 2014?
Provide a short and direct response. 1.08. What is the ratio of the Amount (in current US$) of Middle income in 2008 to that in 2009?
Give a very brief answer. 0.43. What is the ratio of the Amount (in current US$) in South Asia in 2008 to that in 2009?
Your answer should be very brief. 0.86. What is the ratio of the Amount (in current US$) in Bosnia and Herzegovina in 2008 to that in 2009?
Offer a terse response. 0.31. What is the ratio of the Amount (in current US$) of Middle income in 2008 to that in 2010?
Give a very brief answer. 0.38. What is the ratio of the Amount (in current US$) in South Asia in 2008 to that in 2010?
Offer a terse response. 0.69. What is the ratio of the Amount (in current US$) of Bosnia and Herzegovina in 2008 to that in 2010?
Give a very brief answer. 0.21. What is the ratio of the Amount (in current US$) of Middle income in 2008 to that in 2011?
Your answer should be very brief. 0.83. What is the ratio of the Amount (in current US$) of South Asia in 2008 to that in 2011?
Ensure brevity in your answer.  0.96. What is the ratio of the Amount (in current US$) of Bosnia and Herzegovina in 2008 to that in 2011?
Your answer should be compact. 0.33. What is the ratio of the Amount (in current US$) of Middle income in 2008 to that in 2012?
Provide a succinct answer. 0.82. What is the ratio of the Amount (in current US$) in South Asia in 2008 to that in 2012?
Provide a succinct answer. 1.85. What is the ratio of the Amount (in current US$) in Bosnia and Herzegovina in 2008 to that in 2012?
Give a very brief answer. 0.19. What is the ratio of the Amount (in current US$) of Middle income in 2008 to that in 2013?
Offer a very short reply. 0.95. What is the ratio of the Amount (in current US$) of South Asia in 2008 to that in 2013?
Your answer should be compact. 4.07. What is the ratio of the Amount (in current US$) in Bosnia and Herzegovina in 2008 to that in 2013?
Give a very brief answer. 0.13. What is the ratio of the Amount (in current US$) of Middle income in 2008 to that in 2014?
Your answer should be compact. 0.69. What is the ratio of the Amount (in current US$) in South Asia in 2008 to that in 2014?
Offer a terse response. 1.27. What is the ratio of the Amount (in current US$) in Bosnia and Herzegovina in 2008 to that in 2014?
Your response must be concise. 0.14. What is the ratio of the Amount (in current US$) of Middle income in 2009 to that in 2010?
Your answer should be very brief. 0.9. What is the ratio of the Amount (in current US$) of South Asia in 2009 to that in 2010?
Make the answer very short. 0.8. What is the ratio of the Amount (in current US$) in Bosnia and Herzegovina in 2009 to that in 2010?
Your answer should be very brief. 0.67. What is the ratio of the Amount (in current US$) of Middle income in 2009 to that in 2011?
Keep it short and to the point. 1.95. What is the ratio of the Amount (in current US$) in South Asia in 2009 to that in 2011?
Provide a short and direct response. 1.12. What is the ratio of the Amount (in current US$) of Bosnia and Herzegovina in 2009 to that in 2011?
Keep it short and to the point. 1.07. What is the ratio of the Amount (in current US$) in Middle income in 2009 to that in 2012?
Offer a very short reply. 1.92. What is the ratio of the Amount (in current US$) of South Asia in 2009 to that in 2012?
Provide a succinct answer. 2.15. What is the ratio of the Amount (in current US$) in Bosnia and Herzegovina in 2009 to that in 2012?
Your response must be concise. 0.63. What is the ratio of the Amount (in current US$) in Middle income in 2009 to that in 2013?
Provide a short and direct response. 2.23. What is the ratio of the Amount (in current US$) in South Asia in 2009 to that in 2013?
Your answer should be compact. 4.72. What is the ratio of the Amount (in current US$) in Bosnia and Herzegovina in 2009 to that in 2013?
Provide a short and direct response. 0.43. What is the ratio of the Amount (in current US$) of Middle income in 2009 to that in 2014?
Make the answer very short. 1.62. What is the ratio of the Amount (in current US$) of South Asia in 2009 to that in 2014?
Your answer should be very brief. 1.47. What is the ratio of the Amount (in current US$) in Bosnia and Herzegovina in 2009 to that in 2014?
Ensure brevity in your answer.  0.47. What is the ratio of the Amount (in current US$) of Tonga in 2009 to that in 2014?
Your answer should be very brief. 0.02. What is the ratio of the Amount (in current US$) in Middle income in 2010 to that in 2011?
Ensure brevity in your answer.  2.16. What is the ratio of the Amount (in current US$) of South Asia in 2010 to that in 2011?
Provide a succinct answer. 1.39. What is the ratio of the Amount (in current US$) in Bosnia and Herzegovina in 2010 to that in 2011?
Your response must be concise. 1.59. What is the ratio of the Amount (in current US$) of Middle income in 2010 to that in 2012?
Provide a short and direct response. 2.12. What is the ratio of the Amount (in current US$) in South Asia in 2010 to that in 2012?
Offer a terse response. 2.67. What is the ratio of the Amount (in current US$) in Bosnia and Herzegovina in 2010 to that in 2012?
Give a very brief answer. 0.93. What is the ratio of the Amount (in current US$) in Middle income in 2010 to that in 2013?
Provide a succinct answer. 2.47. What is the ratio of the Amount (in current US$) in South Asia in 2010 to that in 2013?
Your answer should be compact. 5.88. What is the ratio of the Amount (in current US$) of Bosnia and Herzegovina in 2010 to that in 2013?
Your answer should be very brief. 0.64. What is the ratio of the Amount (in current US$) of Middle income in 2010 to that in 2014?
Ensure brevity in your answer.  1.79. What is the ratio of the Amount (in current US$) in South Asia in 2010 to that in 2014?
Provide a short and direct response. 1.83. What is the ratio of the Amount (in current US$) in Bosnia and Herzegovina in 2010 to that in 2014?
Your response must be concise. 0.7. What is the ratio of the Amount (in current US$) of Middle income in 2011 to that in 2012?
Your response must be concise. 0.98. What is the ratio of the Amount (in current US$) in South Asia in 2011 to that in 2012?
Provide a succinct answer. 1.92. What is the ratio of the Amount (in current US$) in Bosnia and Herzegovina in 2011 to that in 2012?
Your answer should be compact. 0.59. What is the ratio of the Amount (in current US$) in Middle income in 2011 to that in 2013?
Give a very brief answer. 1.14. What is the ratio of the Amount (in current US$) in South Asia in 2011 to that in 2013?
Give a very brief answer. 4.22. What is the ratio of the Amount (in current US$) in Bosnia and Herzegovina in 2011 to that in 2013?
Your answer should be compact. 0.4. What is the ratio of the Amount (in current US$) of Middle income in 2011 to that in 2014?
Your answer should be very brief. 0.83. What is the ratio of the Amount (in current US$) of South Asia in 2011 to that in 2014?
Give a very brief answer. 1.31. What is the ratio of the Amount (in current US$) of Bosnia and Herzegovina in 2011 to that in 2014?
Ensure brevity in your answer.  0.44. What is the ratio of the Amount (in current US$) of Middle income in 2012 to that in 2013?
Provide a short and direct response. 1.16. What is the ratio of the Amount (in current US$) in South Asia in 2012 to that in 2013?
Offer a terse response. 2.2. What is the ratio of the Amount (in current US$) in Bosnia and Herzegovina in 2012 to that in 2013?
Offer a very short reply. 0.69. What is the ratio of the Amount (in current US$) in Middle income in 2012 to that in 2014?
Provide a succinct answer. 0.84. What is the ratio of the Amount (in current US$) in South Asia in 2012 to that in 2014?
Keep it short and to the point. 0.68. What is the ratio of the Amount (in current US$) of Bosnia and Herzegovina in 2012 to that in 2014?
Provide a succinct answer. 0.75. What is the ratio of the Amount (in current US$) of Middle income in 2013 to that in 2014?
Provide a short and direct response. 0.72. What is the ratio of the Amount (in current US$) of South Asia in 2013 to that in 2014?
Your response must be concise. 0.31. What is the ratio of the Amount (in current US$) in Bosnia and Herzegovina in 2013 to that in 2014?
Your response must be concise. 1.09. What is the difference between the highest and the second highest Amount (in current US$) in Middle income?
Ensure brevity in your answer.  4.38e+09. What is the difference between the highest and the second highest Amount (in current US$) of South Asia?
Offer a very short reply. 1.39e+09. What is the difference between the highest and the second highest Amount (in current US$) in Bosnia and Herzegovina?
Make the answer very short. 3.45e+07. What is the difference between the highest and the second highest Amount (in current US$) of Tonga?
Offer a very short reply. 1.64e+05. What is the difference between the highest and the lowest Amount (in current US$) in Middle income?
Offer a very short reply. 2.99e+1. What is the difference between the highest and the lowest Amount (in current US$) of South Asia?
Give a very brief answer. 5.83e+09. What is the difference between the highest and the lowest Amount (in current US$) in Bosnia and Herzegovina?
Offer a terse response. 3.78e+08. What is the difference between the highest and the lowest Amount (in current US$) of Tonga?
Keep it short and to the point. 2.32e+06. 